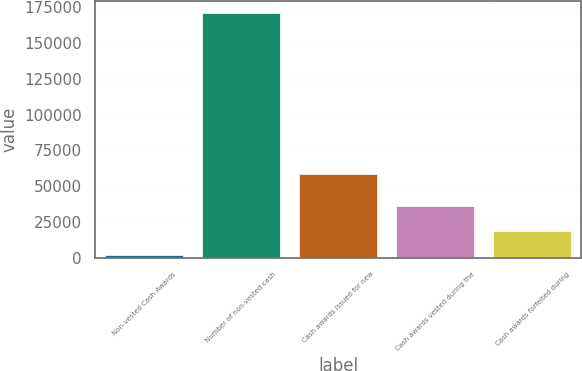Convert chart. <chart><loc_0><loc_0><loc_500><loc_500><bar_chart><fcel>Non-vested Cash Awards<fcel>Number of non-vested cash<fcel>Cash awards issued for new<fcel>Cash awards vested during the<fcel>Cash awards forfeited during<nl><fcel>2013<fcel>170848<fcel>58348<fcel>35780<fcel>18896.5<nl></chart> 